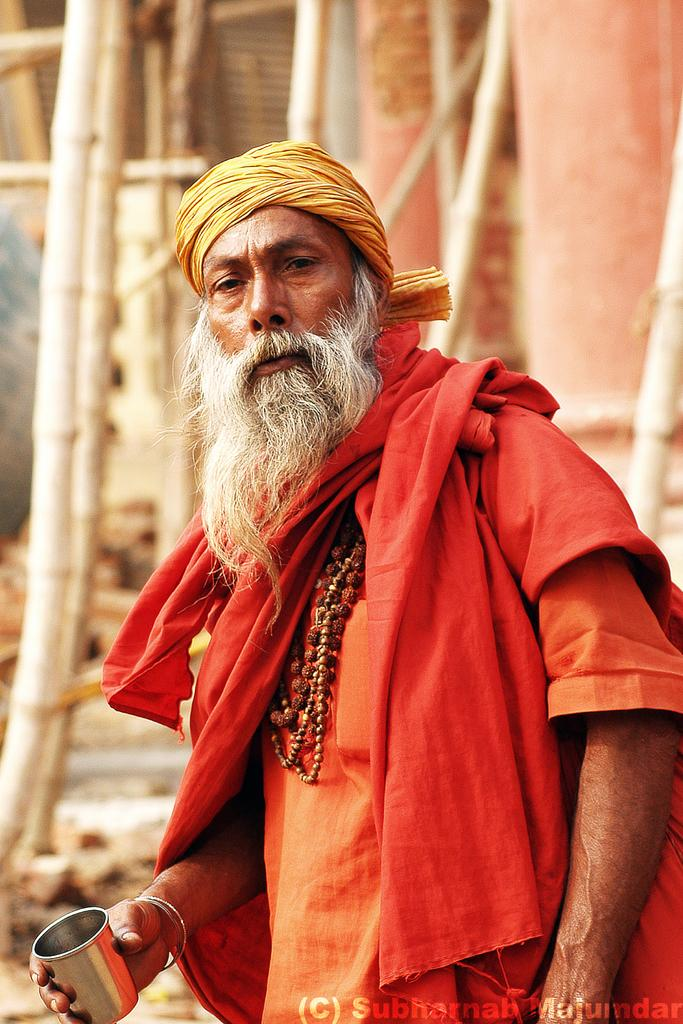Who is present in the image? There is a person in the image. What is the person wearing? The person is wearing an orange dress. What object is the person holding? The person is holding a glass. What can be seen in the background of the image? There are wooden sticks visible in the background of the image. What type of knowledge is being shared in the image? There is no indication of knowledge being shared in the image; it simply shows a person holding a glass. 